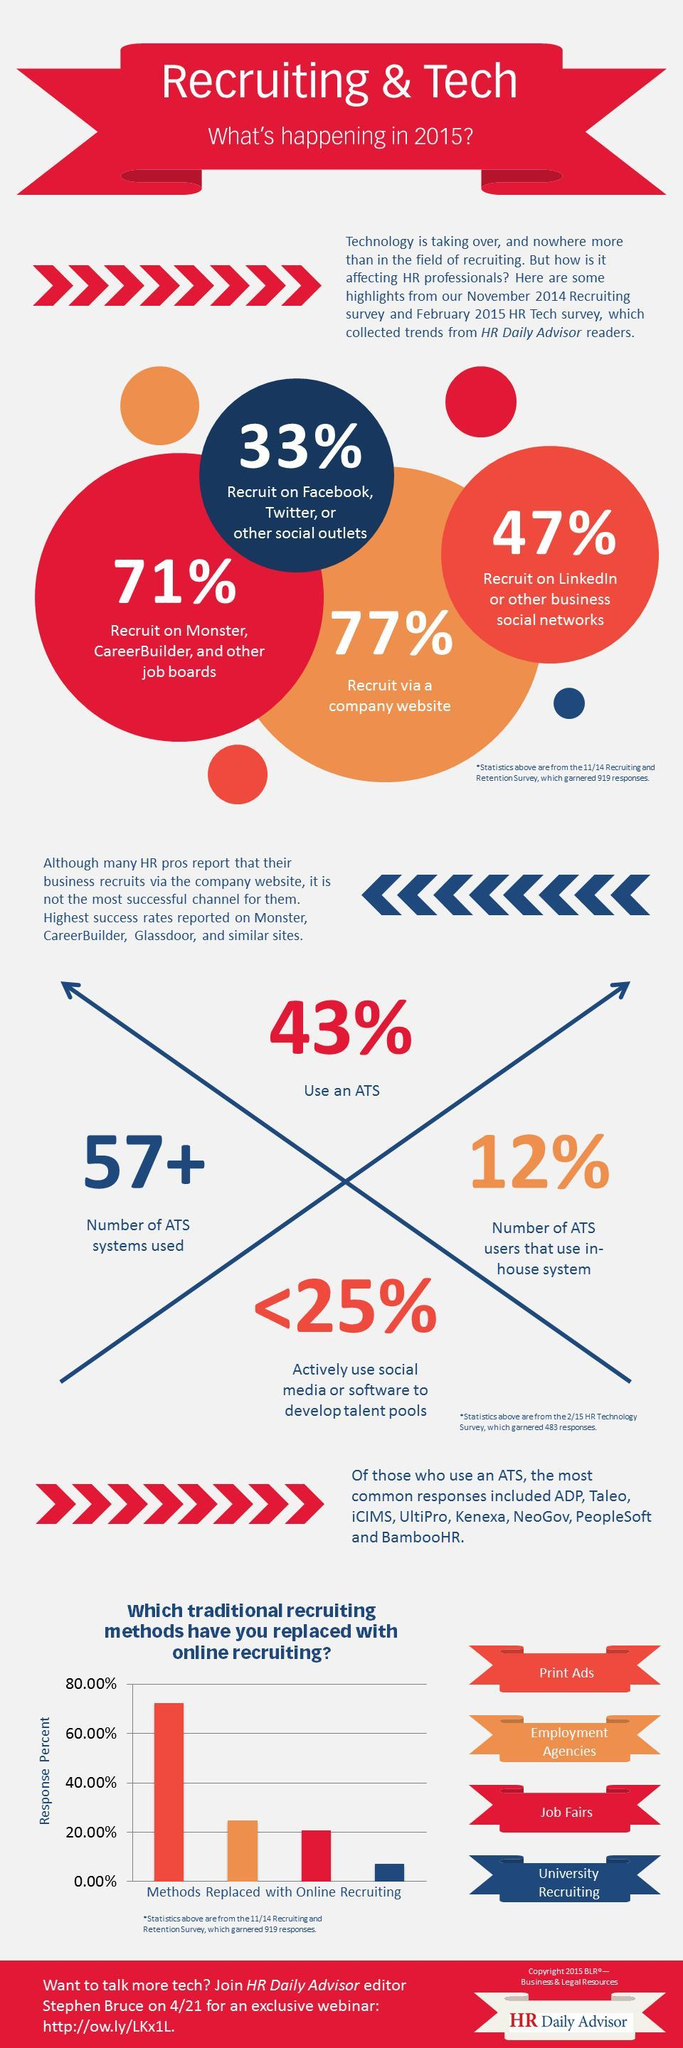What amount of Job Fairs placements have replaced with online recruiting?
Answer the question with a short phrase. 20.00% What is the color code given to "University Recruiting"- red, green, blue, orange? blue How many ways of employee recruitment other than social media recruitment are listed? 3 What percentage of employees are recruiting through LinkedIn? 71% What percentage of employees recruited are through the Career Builder employment site, etc.? 77% 